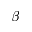<formula> <loc_0><loc_0><loc_500><loc_500>\bar { \beta }</formula> 